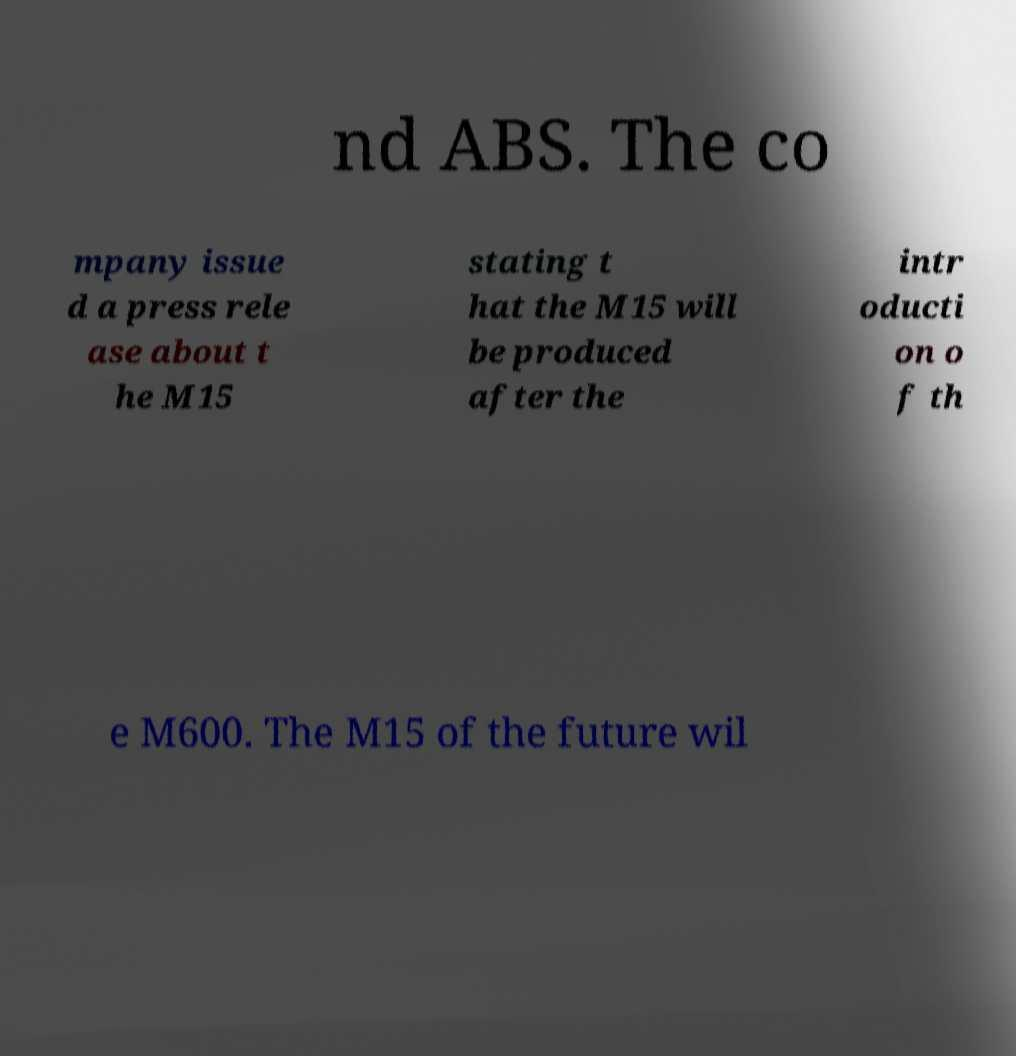There's text embedded in this image that I need extracted. Can you transcribe it verbatim? nd ABS. The co mpany issue d a press rele ase about t he M15 stating t hat the M15 will be produced after the intr oducti on o f th e M600. The M15 of the future wil 